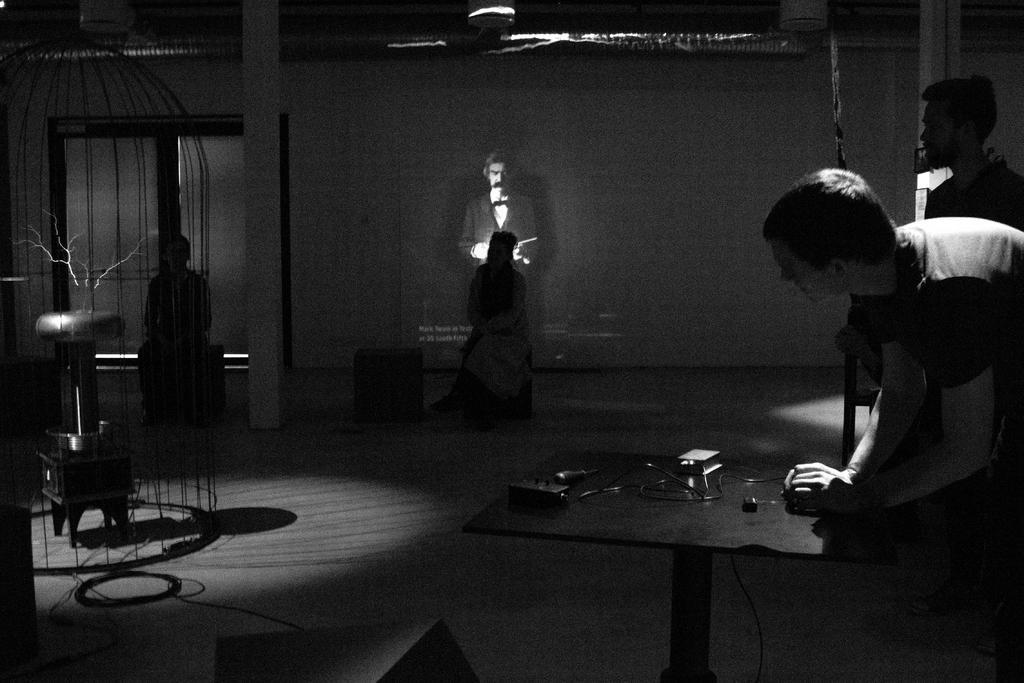How would you summarize this image in a sentence or two? In this image we can see a man is standing, in front here is the table, here is the wire, here a woman is sitting, here is the wall. 